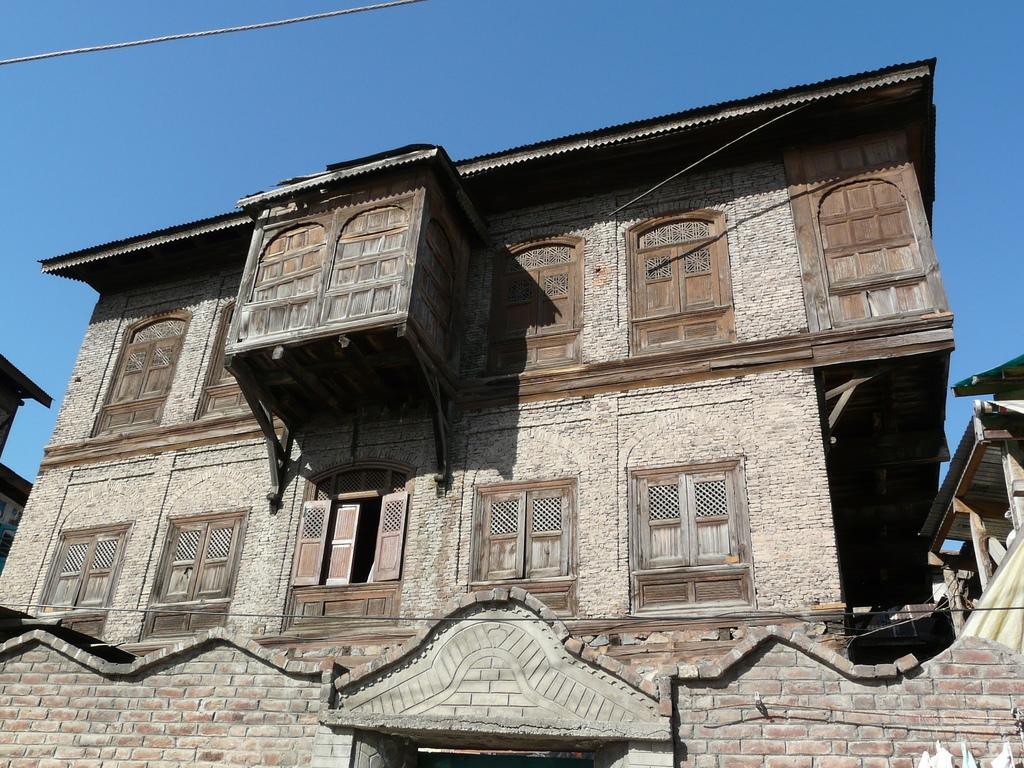What type of structure is present in the image? There is a building in the image. What feature can be seen on the building? The building has windows. What colors are used to depict the building in the image? The building is in ash and brown color. What can be seen in the background of the image? The blue sky is visible in the background of the image. What type of sweater is the building wearing in the image? Buildings do not wear sweaters; the question is not applicable to the image. 